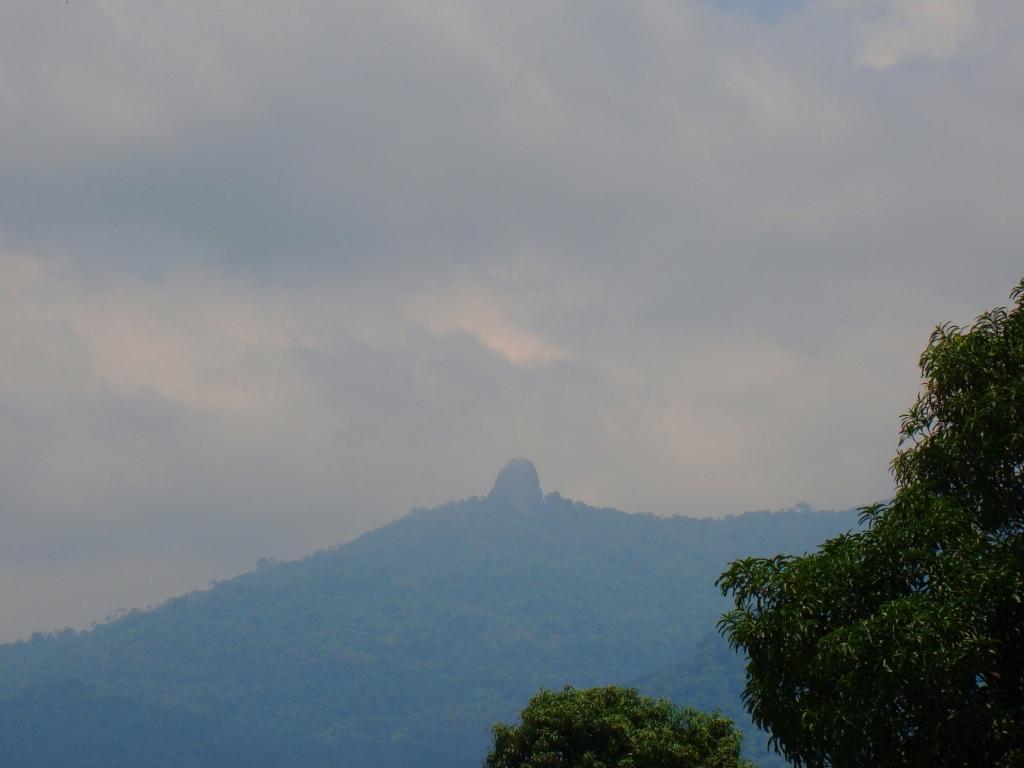Could you give a brief overview of what you see in this image? Here in this picture, in the middle we can see mountains that are covered with plants and trees and in the front also we can see trees present and we can see the sky is fully covered with clouds. 